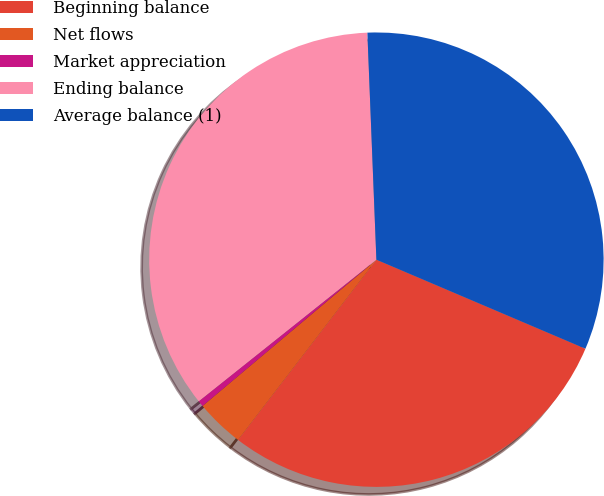Convert chart. <chart><loc_0><loc_0><loc_500><loc_500><pie_chart><fcel>Beginning balance<fcel>Net flows<fcel>Market appreciation<fcel>Ending balance<fcel>Average balance (1)<nl><fcel>29.01%<fcel>3.45%<fcel>0.42%<fcel>35.08%<fcel>32.04%<nl></chart> 